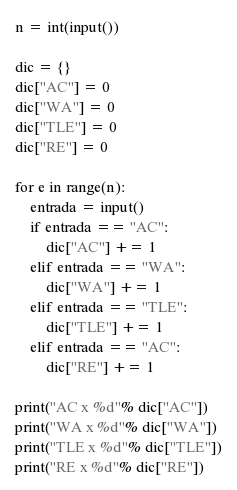<code> <loc_0><loc_0><loc_500><loc_500><_Python_>n = int(input())

dic = {}
dic["AC"] = 0
dic["WA"] = 0
dic["TLE"] = 0
dic["RE"] = 0

for e in range(n):
	entrada = input()
	if entrada == "AC":
		dic["AC"] += 1
	elif entrada == "WA":
		dic["WA"] += 1
	elif entrada == "TLE":
		dic["TLE"] += 1
	elif entrada == "AC":
		dic["RE"] += 1
		
print("AC x %d"% dic["AC"])
print("WA x %d"% dic["WA"])
print("TLE x %d"% dic["TLE"])
print("RE x %d"% dic["RE"])
</code> 